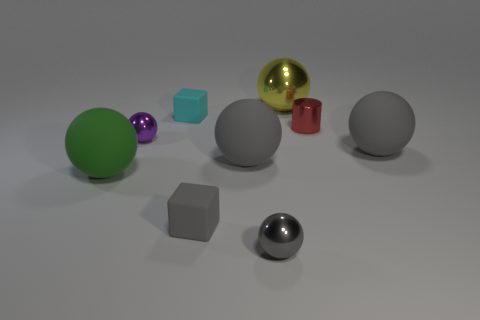Is there a large purple rubber object?
Ensure brevity in your answer.  No. Does the large matte object on the left side of the tiny cyan rubber object have the same shape as the rubber object to the right of the gray shiny object?
Your response must be concise. Yes. What number of tiny things are red spheres or cyan objects?
Provide a short and direct response. 1. There is a tiny thing that is made of the same material as the small cyan cube; what is its shape?
Make the answer very short. Cube. Does the purple shiny object have the same shape as the red shiny object?
Your answer should be compact. No. The metal cylinder is what color?
Keep it short and to the point. Red. What number of things are either small cyan things or big blue metallic cylinders?
Provide a succinct answer. 1. Are there any other things that are the same material as the big yellow object?
Ensure brevity in your answer.  Yes. Is the number of large metal objects in front of the small cyan rubber block less than the number of small yellow metallic spheres?
Keep it short and to the point. No. Are there more large gray objects that are behind the purple ball than large spheres that are behind the big yellow sphere?
Your answer should be very brief. No. 